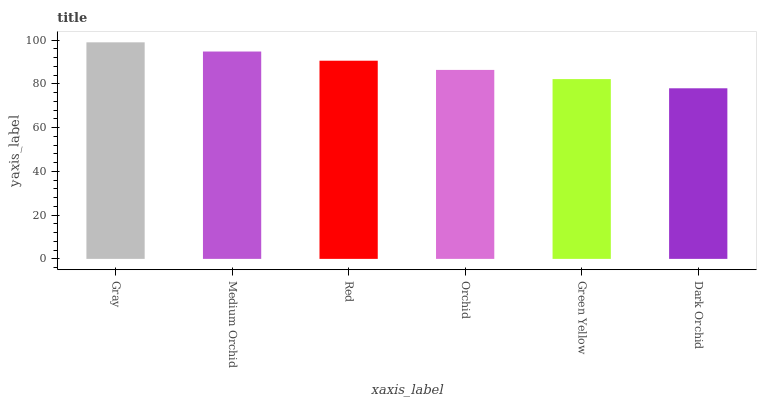Is Medium Orchid the minimum?
Answer yes or no. No. Is Medium Orchid the maximum?
Answer yes or no. No. Is Gray greater than Medium Orchid?
Answer yes or no. Yes. Is Medium Orchid less than Gray?
Answer yes or no. Yes. Is Medium Orchid greater than Gray?
Answer yes or no. No. Is Gray less than Medium Orchid?
Answer yes or no. No. Is Red the high median?
Answer yes or no. Yes. Is Orchid the low median?
Answer yes or no. Yes. Is Dark Orchid the high median?
Answer yes or no. No. Is Gray the low median?
Answer yes or no. No. 